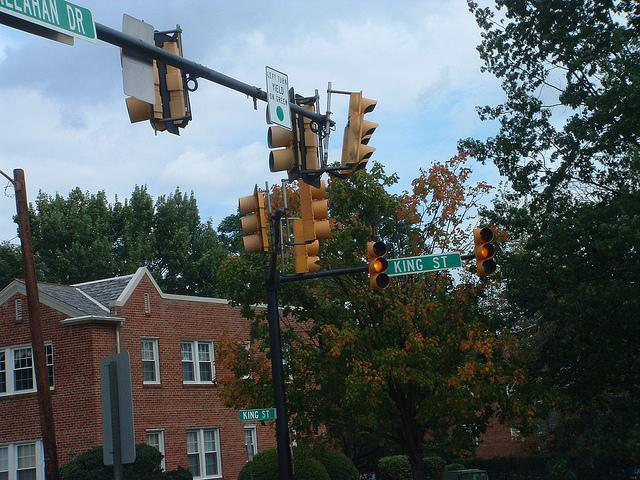Who would be married to the person that is listed on the street name? queen 